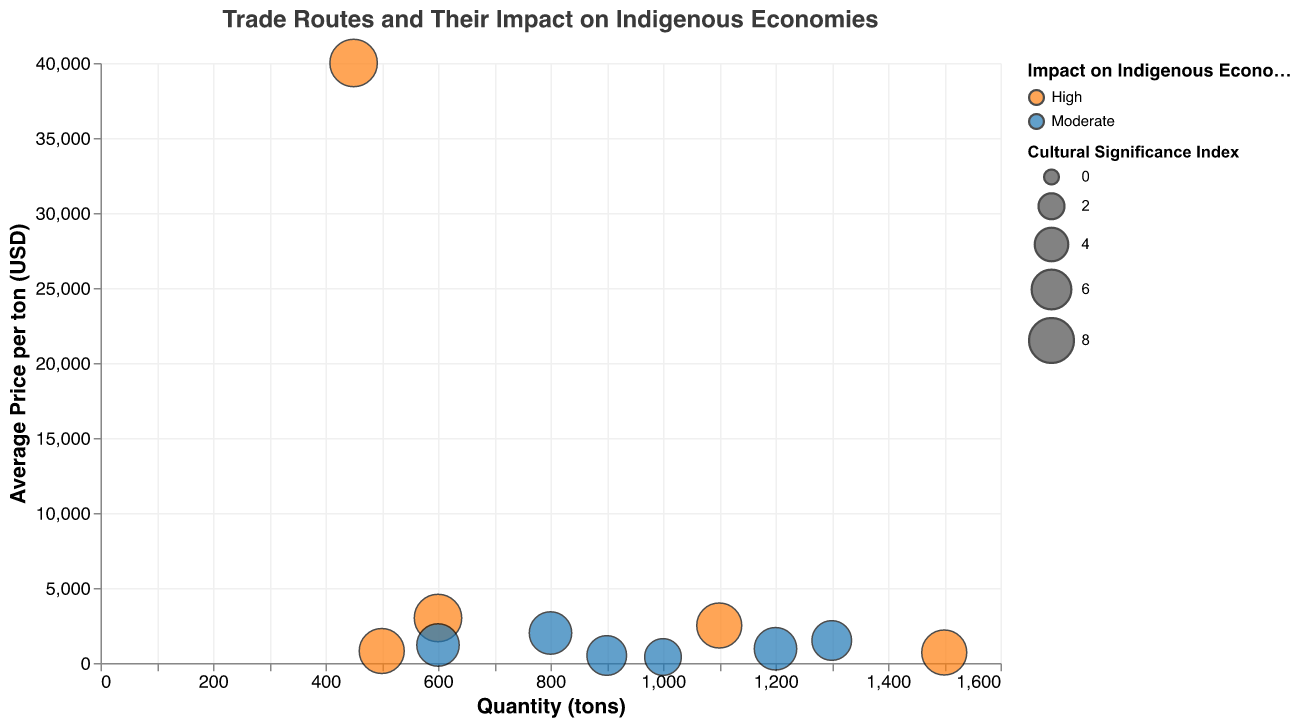What is the title of the figure? The title of the figure is visually presented at the top of the chart. The title text is "Trade Routes and Their Impact on Indigenous Economies".
Answer: Trade Routes and Their Impact on Indigenous Economies How many data points are represented in the bubble chart? Each bubble in the chart represents a data point, and by counting all the bubbles, we determine the total number of data points. There are 11 data points from the provided data.
Answer: 11 Which region has the highest quantity of the commodity? To find the region with the highest quantity, we look for the bubble farthest to the right on the x-axis. The Pacific Northwest has a quantity of 1500 tons of Salmon, which is the highest.
Answer: Pacific Northwest What is the average price per ton for the Cacao Beans commodity? By finding the Cacao Beans bubble on the chart and reading its corresponding y-axis value, we see that the average price per ton for Cacao Beans is 3000 USD.
Answer: 3000 USD Which commodity has a high impact on the indigenous economy and a cultural significance index of 8? We locate the bubbles with orange color (indicating "High" impact) and then check the size of the bubbles that match a cultural significance index of 8. The commodities are Quinoa, Salmon, and Olive Oil; confirm by reviewing the chart.
Answer: Quinoa, Salmon, Olive Oil Compare the average price per ton of Gold and Olive Oil. Which one is higher? Locate the bubbles for Gold and Olive Oil and compare their y-axis values. Gold has an average price per ton of 40000 USD, while Olive Oil has 2500 USD. Therefore, Gold is higher.
Answer: Gold What is the combined quantity of Rubber and Fish? Locate the Rubber and Fish bubbles and sum their values on the x-axis. Rubber has 1000 tons, and Fish has 900 tons. The combined quantity is 1000 + 900 = 1900 tons.
Answer: 1900 tons Which commodity has the largest bubble representing cultural significance index? Larger bubbles denote higher cultural significance indexes. The largest bubbles in the chart have a cultural significance index of 9. Locate these, noting that Cacao Beans and Gold have the largest bubbles.
Answer: Cacao Beans, Gold Which regions have a "Moderate" impact on the indigenous economy and a quantity greater than 1000 tons? To answer, locate the blue colored bubbles (Moderate impact) and check which of these have an x-axis value greater than 1000 tons. Bison Hides in the Great Plains and Cotton in the Indus Valley meet these criteria.
Answer: Great Plains, Indus Valley 